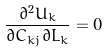<formula> <loc_0><loc_0><loc_500><loc_500>\frac { \partial ^ { 2 } U _ { k } } { \partial C _ { k j } \partial L _ { k } } = 0</formula> 